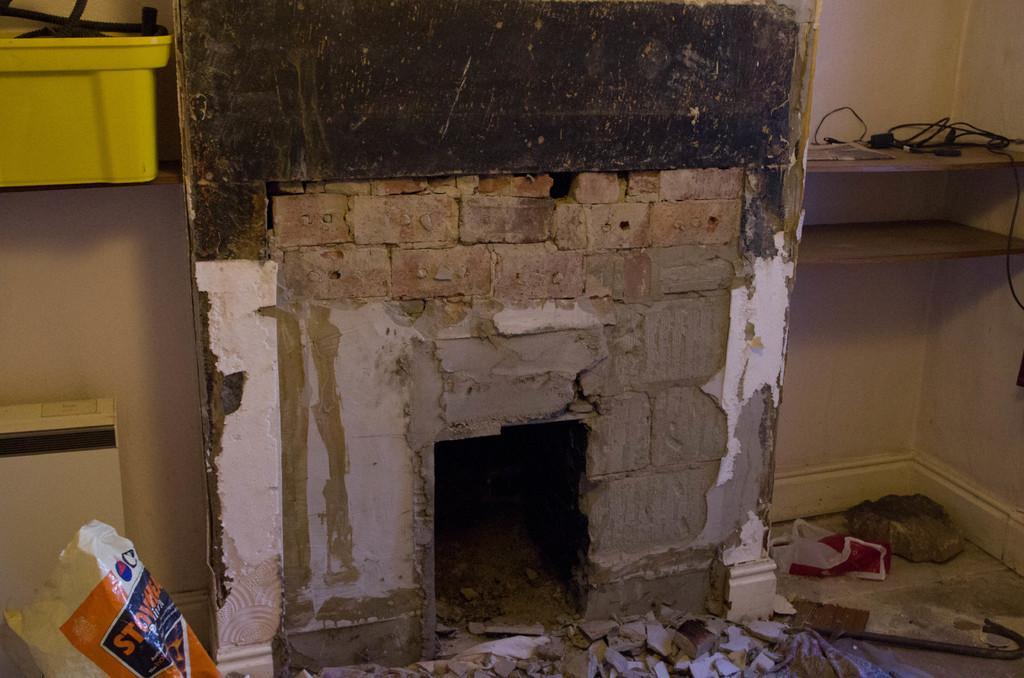Could you give a brief overview of what you see in this image? In this image we can see walls, container, cables and a polythene bag on the floor. 